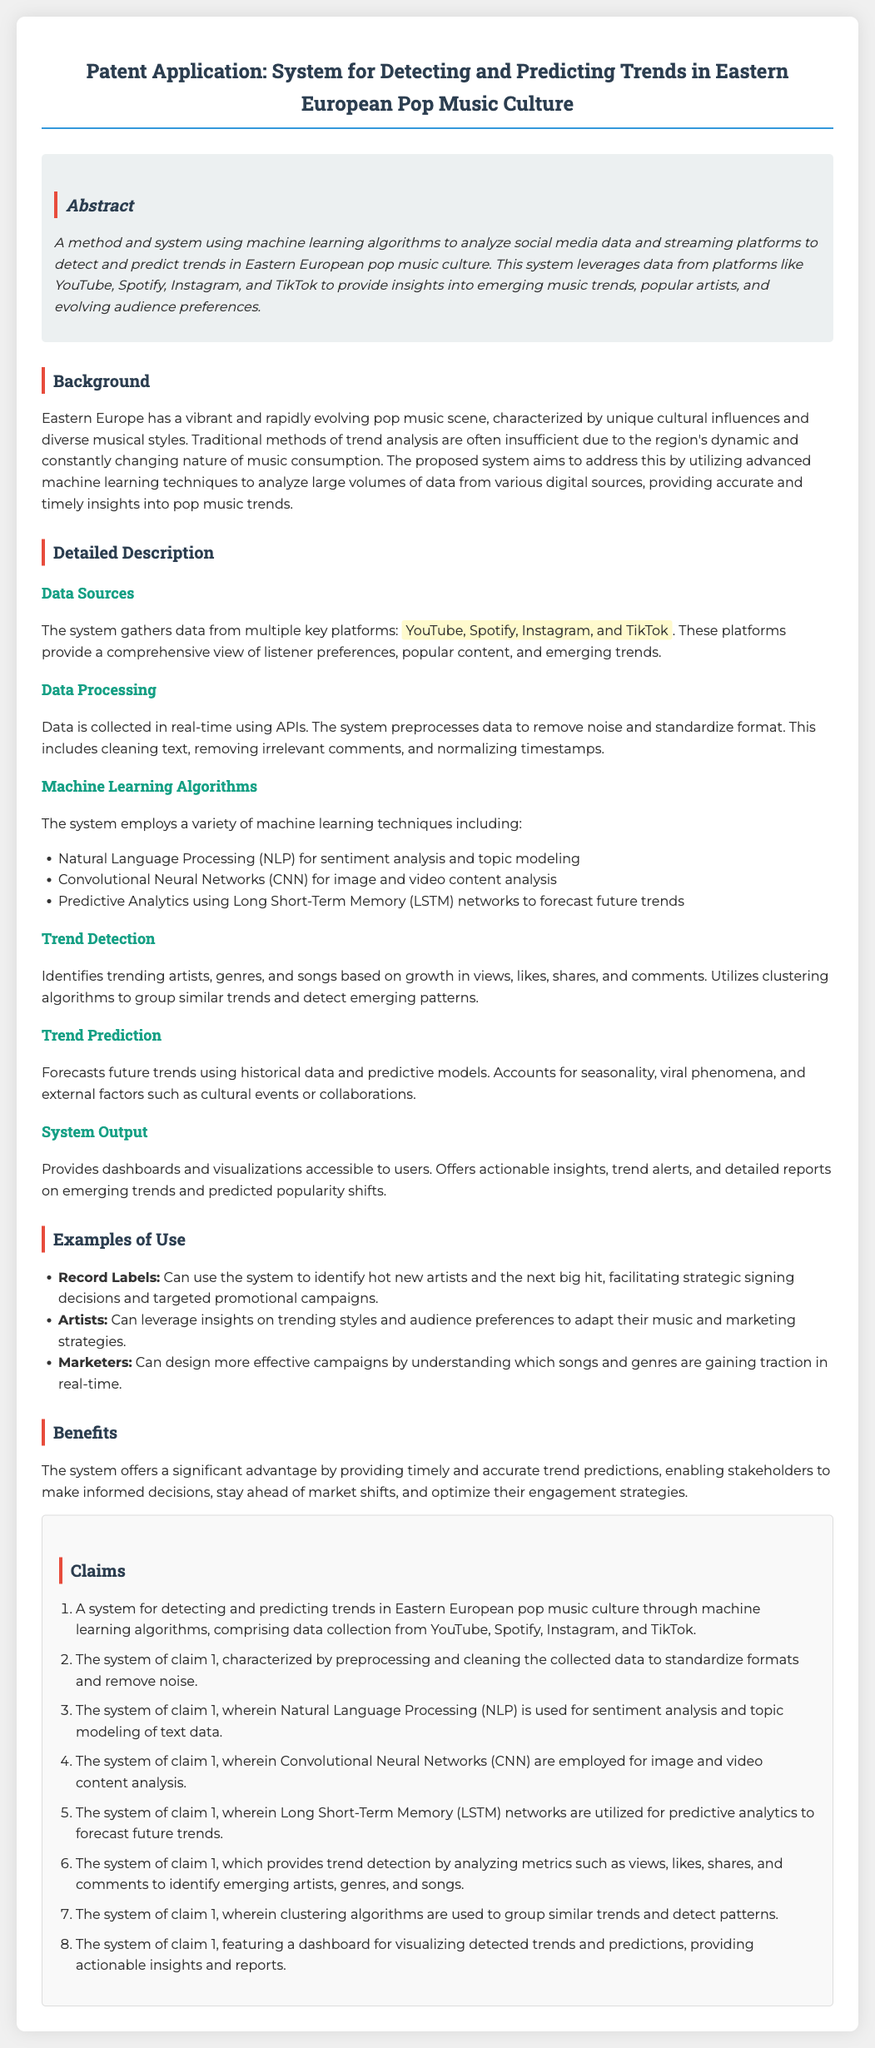What is the purpose of the system? The system aims to detect and predict trends in Eastern European pop music culture using machine learning algorithms.
Answer: Detecting and predicting trends in Eastern European pop music culture Which platforms does the system collect data from? The system gathers data from multiple key platforms mentioned in the document.
Answer: YouTube, Spotify, Instagram, and TikTok What technique is used for sentiment analysis? The document mentions the use of a specific machine learning technique for sentiment analysis, indicating its role in the system.
Answer: Natural Language Processing (NLP) What is the main advantage of the system? The document outlines a significant benefit provided by the system for stakeholders in the music industry.
Answer: Timely and accurate trend predictions Which machine learning algorithm is used for predictive analytics? The system incorporates a particular type of network for forecasting future trends, specified in the document.
Answer: Long Short-Term Memory (LSTM) How does the system identify trending artists? The document describes metrics analyzed by the system for identifying trends in artists, genres, and songs.
Answer: Growth in views, likes, shares, and comments What do record labels use the system for? The document provides an example of how a specific type of user can utilize insights from the system.
Answer: Identify hot new artists and the next big hit What type of output does the system provide? The document specifies the type of user interface and insights generated by the system.
Answer: Dashboards and visualizations 